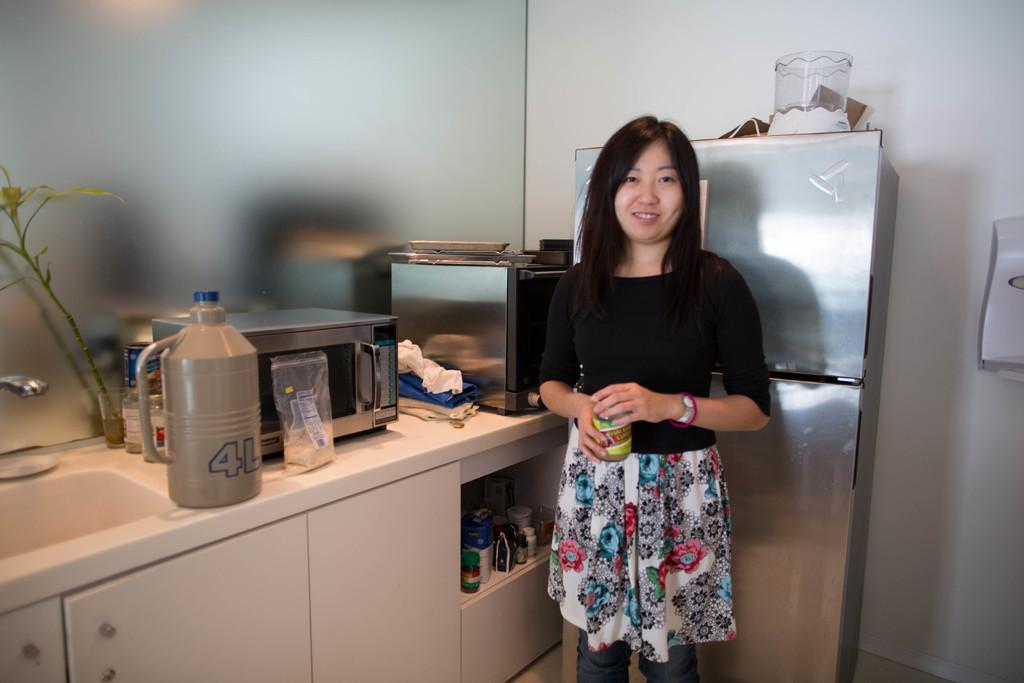<image>
Provide a brief description of the given image. A young woman stands next to a refrigerator near a four liter bottle. 